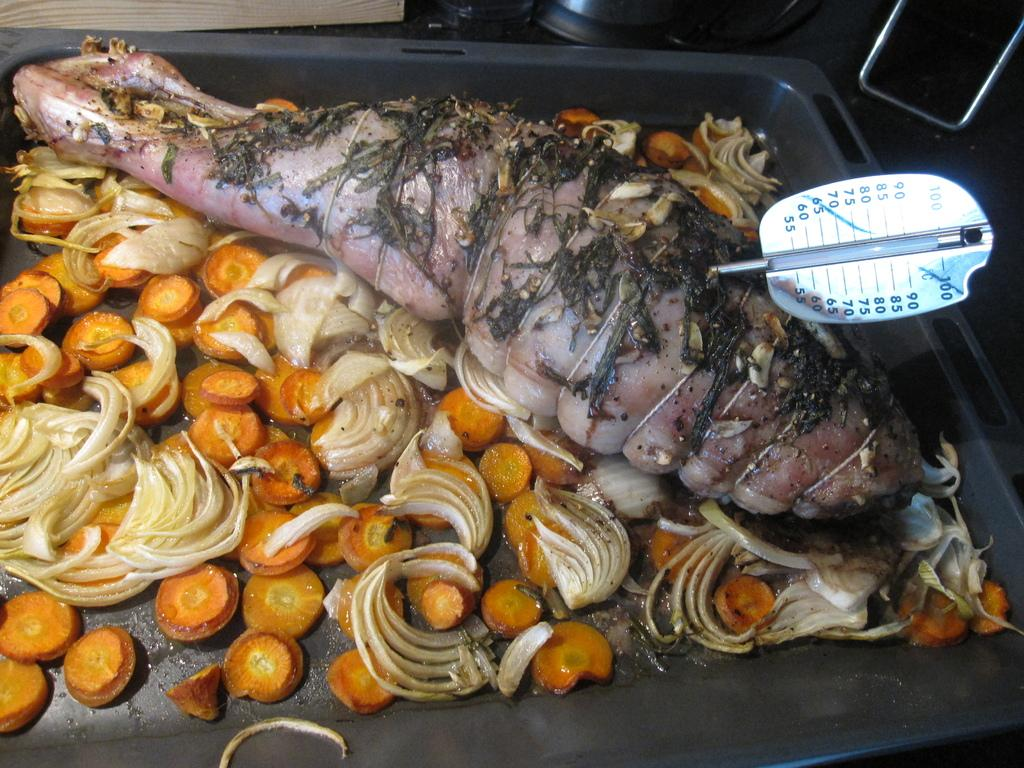What is the main food item on the tray in the image? There is a food item on a tray in the image, but the specific type of food is not mentioned. What type of vegetable slices can be seen on the tray? There are carrot slices and onion slices on the tray. Is there any additional information provided about the food item? Yes, there is a display card on the food item. What is the name of the person who started the war in the image? There is no mention of a war or a person's name in the image. The image only shows a food item on a tray with carrot and onion slices and a display card. 